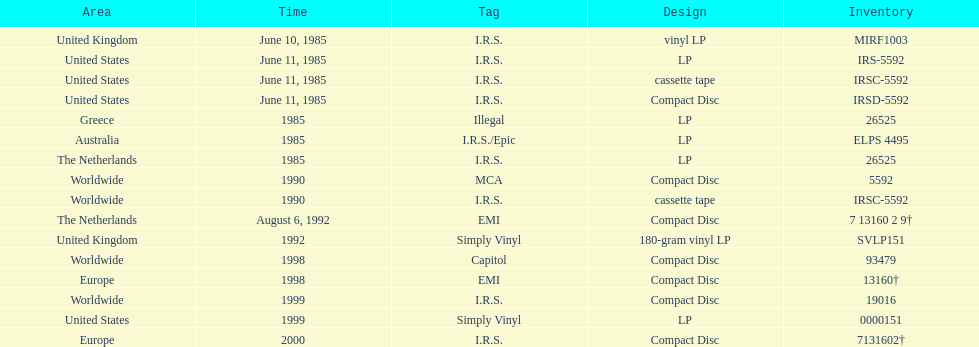What is the highest number of consecutive lp format releases? 3. 